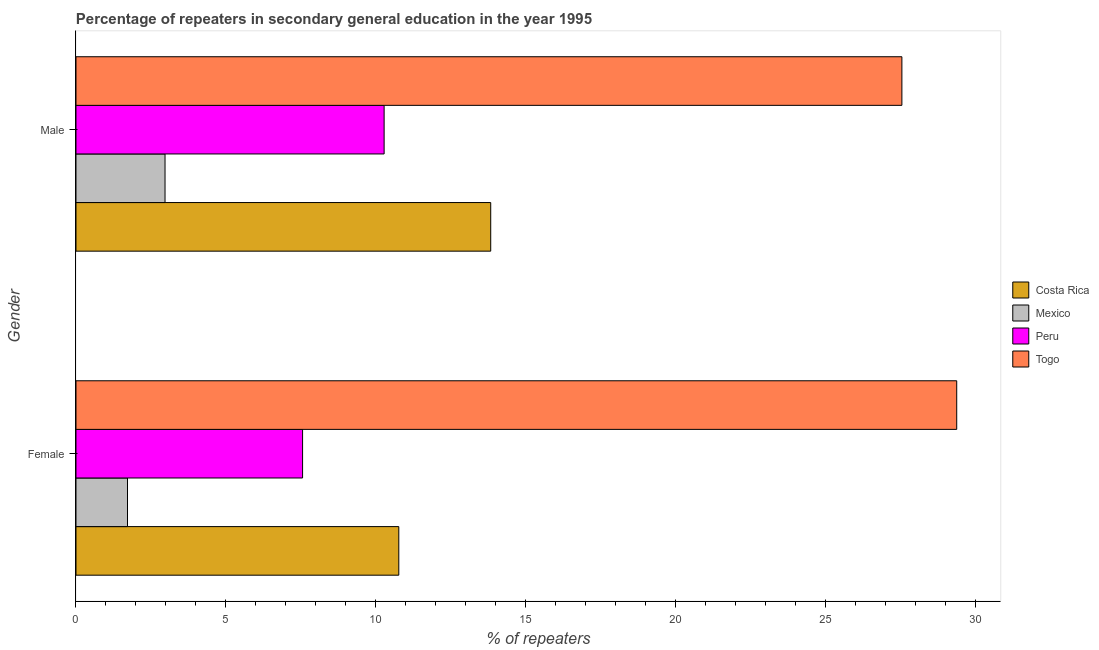How many different coloured bars are there?
Offer a very short reply. 4. How many groups of bars are there?
Make the answer very short. 2. Are the number of bars per tick equal to the number of legend labels?
Make the answer very short. Yes. What is the label of the 2nd group of bars from the top?
Your answer should be compact. Female. What is the percentage of female repeaters in Mexico?
Keep it short and to the point. 1.72. Across all countries, what is the maximum percentage of male repeaters?
Provide a short and direct response. 27.54. Across all countries, what is the minimum percentage of female repeaters?
Ensure brevity in your answer.  1.72. In which country was the percentage of male repeaters maximum?
Provide a succinct answer. Togo. In which country was the percentage of female repeaters minimum?
Provide a succinct answer. Mexico. What is the total percentage of male repeaters in the graph?
Make the answer very short. 54.61. What is the difference between the percentage of male repeaters in Togo and that in Costa Rica?
Provide a succinct answer. 13.71. What is the difference between the percentage of male repeaters in Togo and the percentage of female repeaters in Peru?
Keep it short and to the point. 19.98. What is the average percentage of male repeaters per country?
Provide a succinct answer. 13.65. What is the difference between the percentage of male repeaters and percentage of female repeaters in Mexico?
Your answer should be very brief. 1.25. In how many countries, is the percentage of female repeaters greater than 1 %?
Make the answer very short. 4. What is the ratio of the percentage of female repeaters in Togo to that in Peru?
Your response must be concise. 3.89. Is the percentage of female repeaters in Costa Rica less than that in Mexico?
Keep it short and to the point. No. What does the 2nd bar from the top in Male represents?
Keep it short and to the point. Peru. What does the 4th bar from the bottom in Male represents?
Provide a short and direct response. Togo. How many countries are there in the graph?
Provide a short and direct response. 4. What is the difference between two consecutive major ticks on the X-axis?
Offer a very short reply. 5. Does the graph contain any zero values?
Your response must be concise. No. Does the graph contain grids?
Ensure brevity in your answer.  No. Where does the legend appear in the graph?
Offer a very short reply. Center right. How many legend labels are there?
Provide a succinct answer. 4. What is the title of the graph?
Your answer should be compact. Percentage of repeaters in secondary general education in the year 1995. Does "Denmark" appear as one of the legend labels in the graph?
Offer a very short reply. No. What is the label or title of the X-axis?
Your answer should be very brief. % of repeaters. What is the % of repeaters of Costa Rica in Female?
Provide a succinct answer. 10.76. What is the % of repeaters in Mexico in Female?
Your response must be concise. 1.72. What is the % of repeaters in Peru in Female?
Provide a succinct answer. 7.56. What is the % of repeaters in Togo in Female?
Your answer should be very brief. 29.37. What is the % of repeaters in Costa Rica in Male?
Offer a very short reply. 13.83. What is the % of repeaters of Mexico in Male?
Your response must be concise. 2.97. What is the % of repeaters in Peru in Male?
Provide a succinct answer. 10.27. What is the % of repeaters in Togo in Male?
Keep it short and to the point. 27.54. Across all Gender, what is the maximum % of repeaters of Costa Rica?
Keep it short and to the point. 13.83. Across all Gender, what is the maximum % of repeaters in Mexico?
Ensure brevity in your answer.  2.97. Across all Gender, what is the maximum % of repeaters of Peru?
Offer a very short reply. 10.27. Across all Gender, what is the maximum % of repeaters of Togo?
Your response must be concise. 29.37. Across all Gender, what is the minimum % of repeaters of Costa Rica?
Keep it short and to the point. 10.76. Across all Gender, what is the minimum % of repeaters of Mexico?
Make the answer very short. 1.72. Across all Gender, what is the minimum % of repeaters in Peru?
Your answer should be compact. 7.56. Across all Gender, what is the minimum % of repeaters of Togo?
Offer a terse response. 27.54. What is the total % of repeaters in Costa Rica in the graph?
Provide a short and direct response. 24.59. What is the total % of repeaters of Mexico in the graph?
Offer a terse response. 4.69. What is the total % of repeaters of Peru in the graph?
Your response must be concise. 17.83. What is the total % of repeaters of Togo in the graph?
Ensure brevity in your answer.  56.91. What is the difference between the % of repeaters of Costa Rica in Female and that in Male?
Offer a very short reply. -3.07. What is the difference between the % of repeaters in Mexico in Female and that in Male?
Offer a very short reply. -1.25. What is the difference between the % of repeaters of Peru in Female and that in Male?
Your answer should be very brief. -2.72. What is the difference between the % of repeaters of Togo in Female and that in Male?
Keep it short and to the point. 1.83. What is the difference between the % of repeaters of Costa Rica in Female and the % of repeaters of Mexico in Male?
Your response must be concise. 7.79. What is the difference between the % of repeaters of Costa Rica in Female and the % of repeaters of Peru in Male?
Provide a succinct answer. 0.49. What is the difference between the % of repeaters of Costa Rica in Female and the % of repeaters of Togo in Male?
Provide a short and direct response. -16.78. What is the difference between the % of repeaters of Mexico in Female and the % of repeaters of Peru in Male?
Make the answer very short. -8.56. What is the difference between the % of repeaters in Mexico in Female and the % of repeaters in Togo in Male?
Provide a short and direct response. -25.82. What is the difference between the % of repeaters in Peru in Female and the % of repeaters in Togo in Male?
Your response must be concise. -19.98. What is the average % of repeaters in Costa Rica per Gender?
Your response must be concise. 12.3. What is the average % of repeaters of Mexico per Gender?
Ensure brevity in your answer.  2.34. What is the average % of repeaters of Peru per Gender?
Ensure brevity in your answer.  8.92. What is the average % of repeaters in Togo per Gender?
Give a very brief answer. 28.45. What is the difference between the % of repeaters in Costa Rica and % of repeaters in Mexico in Female?
Provide a succinct answer. 9.05. What is the difference between the % of repeaters of Costa Rica and % of repeaters of Peru in Female?
Offer a very short reply. 3.21. What is the difference between the % of repeaters in Costa Rica and % of repeaters in Togo in Female?
Offer a terse response. -18.6. What is the difference between the % of repeaters in Mexico and % of repeaters in Peru in Female?
Offer a very short reply. -5.84. What is the difference between the % of repeaters of Mexico and % of repeaters of Togo in Female?
Keep it short and to the point. -27.65. What is the difference between the % of repeaters of Peru and % of repeaters of Togo in Female?
Provide a short and direct response. -21.81. What is the difference between the % of repeaters of Costa Rica and % of repeaters of Mexico in Male?
Give a very brief answer. 10.86. What is the difference between the % of repeaters in Costa Rica and % of repeaters in Peru in Male?
Ensure brevity in your answer.  3.55. What is the difference between the % of repeaters of Costa Rica and % of repeaters of Togo in Male?
Give a very brief answer. -13.71. What is the difference between the % of repeaters of Mexico and % of repeaters of Peru in Male?
Your response must be concise. -7.31. What is the difference between the % of repeaters of Mexico and % of repeaters of Togo in Male?
Your response must be concise. -24.57. What is the difference between the % of repeaters of Peru and % of repeaters of Togo in Male?
Make the answer very short. -17.26. What is the ratio of the % of repeaters in Costa Rica in Female to that in Male?
Give a very brief answer. 0.78. What is the ratio of the % of repeaters of Mexico in Female to that in Male?
Make the answer very short. 0.58. What is the ratio of the % of repeaters in Peru in Female to that in Male?
Give a very brief answer. 0.74. What is the ratio of the % of repeaters of Togo in Female to that in Male?
Offer a very short reply. 1.07. What is the difference between the highest and the second highest % of repeaters of Costa Rica?
Provide a succinct answer. 3.07. What is the difference between the highest and the second highest % of repeaters of Mexico?
Ensure brevity in your answer.  1.25. What is the difference between the highest and the second highest % of repeaters in Peru?
Offer a terse response. 2.72. What is the difference between the highest and the second highest % of repeaters in Togo?
Provide a short and direct response. 1.83. What is the difference between the highest and the lowest % of repeaters in Costa Rica?
Provide a succinct answer. 3.07. What is the difference between the highest and the lowest % of repeaters of Mexico?
Keep it short and to the point. 1.25. What is the difference between the highest and the lowest % of repeaters of Peru?
Offer a terse response. 2.72. What is the difference between the highest and the lowest % of repeaters in Togo?
Ensure brevity in your answer.  1.83. 